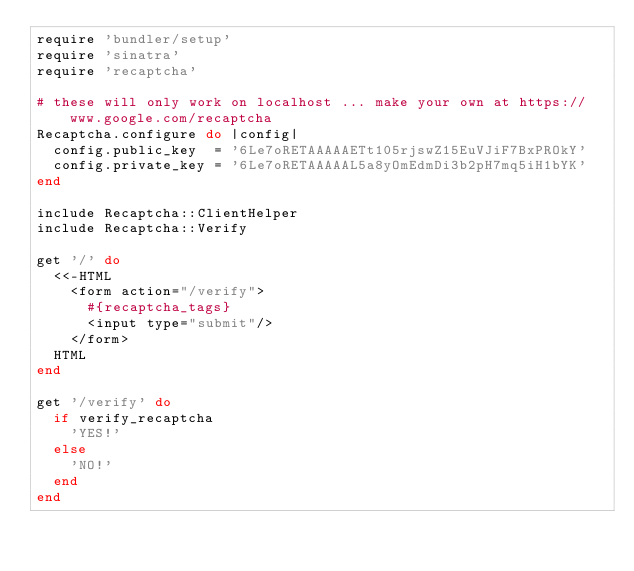<code> <loc_0><loc_0><loc_500><loc_500><_Ruby_>require 'bundler/setup'
require 'sinatra'
require 'recaptcha'

# these will only work on localhost ... make your own at https://www.google.com/recaptcha
Recaptcha.configure do |config|
  config.public_key  = '6Le7oRETAAAAAETt105rjswZ15EuVJiF7BxPROkY'
  config.private_key = '6Le7oRETAAAAAL5a8yOmEdmDi3b2pH7mq5iH1bYK'
end

include Recaptcha::ClientHelper
include Recaptcha::Verify

get '/' do
  <<-HTML
    <form action="/verify">
      #{recaptcha_tags}
      <input type="submit"/>
    </form>
  HTML
end

get '/verify' do
  if verify_recaptcha
    'YES!'
  else
    'NO!'
  end
end
</code> 